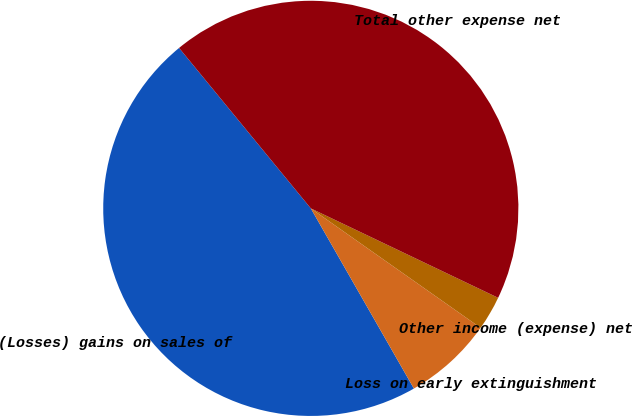<chart> <loc_0><loc_0><loc_500><loc_500><pie_chart><fcel>(Losses) gains on sales of<fcel>Loss on early extinguishment<fcel>Other income (expense) net<fcel>Total other expense net<nl><fcel>47.33%<fcel>6.97%<fcel>2.67%<fcel>43.03%<nl></chart> 